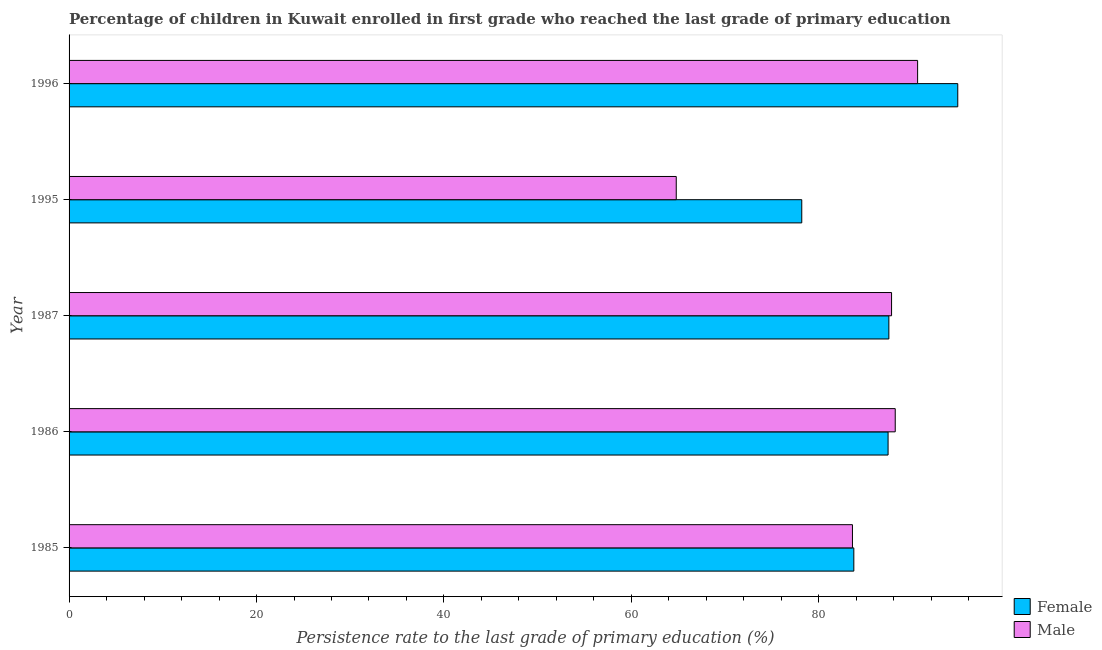How many different coloured bars are there?
Give a very brief answer. 2. Are the number of bars on each tick of the Y-axis equal?
Offer a very short reply. Yes. How many bars are there on the 1st tick from the top?
Offer a terse response. 2. How many bars are there on the 4th tick from the bottom?
Your response must be concise. 2. In how many cases, is the number of bars for a given year not equal to the number of legend labels?
Offer a terse response. 0. What is the persistence rate of male students in 1985?
Give a very brief answer. 83.59. Across all years, what is the maximum persistence rate of male students?
Your answer should be very brief. 90.54. Across all years, what is the minimum persistence rate of female students?
Make the answer very short. 78.18. What is the total persistence rate of female students in the graph?
Provide a short and direct response. 431.61. What is the difference between the persistence rate of female students in 1986 and that in 1996?
Keep it short and to the point. -7.43. What is the difference between the persistence rate of female students in 1985 and the persistence rate of male students in 1987?
Keep it short and to the point. -4.03. What is the average persistence rate of male students per year?
Give a very brief answer. 82.97. In the year 1996, what is the difference between the persistence rate of male students and persistence rate of female students?
Keep it short and to the point. -4.28. What is the ratio of the persistence rate of female students in 1985 to that in 1995?
Give a very brief answer. 1.07. Is the difference between the persistence rate of female students in 1985 and 1986 greater than the difference between the persistence rate of male students in 1985 and 1986?
Your answer should be very brief. Yes. What is the difference between the highest and the second highest persistence rate of female students?
Your answer should be very brief. 7.35. What is the difference between the highest and the lowest persistence rate of male students?
Your answer should be compact. 25.75. In how many years, is the persistence rate of female students greater than the average persistence rate of female students taken over all years?
Provide a short and direct response. 3. Is the sum of the persistence rate of female students in 1986 and 1996 greater than the maximum persistence rate of male students across all years?
Offer a terse response. Yes. How many bars are there?
Your response must be concise. 10. Does the graph contain any zero values?
Give a very brief answer. No. How many legend labels are there?
Ensure brevity in your answer.  2. How are the legend labels stacked?
Your answer should be compact. Vertical. What is the title of the graph?
Provide a succinct answer. Percentage of children in Kuwait enrolled in first grade who reached the last grade of primary education. Does "Foreign liabilities" appear as one of the legend labels in the graph?
Keep it short and to the point. No. What is the label or title of the X-axis?
Keep it short and to the point. Persistence rate to the last grade of primary education (%). What is the label or title of the Y-axis?
Provide a short and direct response. Year. What is the Persistence rate to the last grade of primary education (%) in Female in 1985?
Offer a terse response. 83.74. What is the Persistence rate to the last grade of primary education (%) of Male in 1985?
Your answer should be compact. 83.59. What is the Persistence rate to the last grade of primary education (%) of Female in 1986?
Your answer should be compact. 87.39. What is the Persistence rate to the last grade of primary education (%) of Male in 1986?
Give a very brief answer. 88.15. What is the Persistence rate to the last grade of primary education (%) in Female in 1987?
Your answer should be very brief. 87.47. What is the Persistence rate to the last grade of primary education (%) in Male in 1987?
Provide a short and direct response. 87.76. What is the Persistence rate to the last grade of primary education (%) of Female in 1995?
Ensure brevity in your answer.  78.18. What is the Persistence rate to the last grade of primary education (%) of Male in 1995?
Your response must be concise. 64.79. What is the Persistence rate to the last grade of primary education (%) of Female in 1996?
Offer a very short reply. 94.83. What is the Persistence rate to the last grade of primary education (%) of Male in 1996?
Keep it short and to the point. 90.54. Across all years, what is the maximum Persistence rate to the last grade of primary education (%) of Female?
Offer a very short reply. 94.83. Across all years, what is the maximum Persistence rate to the last grade of primary education (%) of Male?
Keep it short and to the point. 90.54. Across all years, what is the minimum Persistence rate to the last grade of primary education (%) in Female?
Your answer should be very brief. 78.18. Across all years, what is the minimum Persistence rate to the last grade of primary education (%) in Male?
Offer a very short reply. 64.79. What is the total Persistence rate to the last grade of primary education (%) of Female in the graph?
Your answer should be compact. 431.61. What is the total Persistence rate to the last grade of primary education (%) in Male in the graph?
Provide a short and direct response. 414.84. What is the difference between the Persistence rate to the last grade of primary education (%) in Female in 1985 and that in 1986?
Ensure brevity in your answer.  -3.66. What is the difference between the Persistence rate to the last grade of primary education (%) in Male in 1985 and that in 1986?
Your response must be concise. -4.57. What is the difference between the Persistence rate to the last grade of primary education (%) of Female in 1985 and that in 1987?
Give a very brief answer. -3.74. What is the difference between the Persistence rate to the last grade of primary education (%) in Male in 1985 and that in 1987?
Your answer should be compact. -4.17. What is the difference between the Persistence rate to the last grade of primary education (%) in Female in 1985 and that in 1995?
Offer a terse response. 5.55. What is the difference between the Persistence rate to the last grade of primary education (%) of Male in 1985 and that in 1995?
Make the answer very short. 18.8. What is the difference between the Persistence rate to the last grade of primary education (%) in Female in 1985 and that in 1996?
Provide a short and direct response. -11.09. What is the difference between the Persistence rate to the last grade of primary education (%) in Male in 1985 and that in 1996?
Offer a terse response. -6.95. What is the difference between the Persistence rate to the last grade of primary education (%) in Female in 1986 and that in 1987?
Offer a terse response. -0.08. What is the difference between the Persistence rate to the last grade of primary education (%) in Male in 1986 and that in 1987?
Your answer should be compact. 0.39. What is the difference between the Persistence rate to the last grade of primary education (%) in Female in 1986 and that in 1995?
Keep it short and to the point. 9.21. What is the difference between the Persistence rate to the last grade of primary education (%) in Male in 1986 and that in 1995?
Provide a short and direct response. 23.37. What is the difference between the Persistence rate to the last grade of primary education (%) in Female in 1986 and that in 1996?
Provide a short and direct response. -7.43. What is the difference between the Persistence rate to the last grade of primary education (%) in Male in 1986 and that in 1996?
Keep it short and to the point. -2.39. What is the difference between the Persistence rate to the last grade of primary education (%) of Female in 1987 and that in 1995?
Give a very brief answer. 9.29. What is the difference between the Persistence rate to the last grade of primary education (%) of Male in 1987 and that in 1995?
Give a very brief answer. 22.97. What is the difference between the Persistence rate to the last grade of primary education (%) of Female in 1987 and that in 1996?
Your answer should be compact. -7.35. What is the difference between the Persistence rate to the last grade of primary education (%) of Male in 1987 and that in 1996?
Your answer should be compact. -2.78. What is the difference between the Persistence rate to the last grade of primary education (%) in Female in 1995 and that in 1996?
Your response must be concise. -16.64. What is the difference between the Persistence rate to the last grade of primary education (%) in Male in 1995 and that in 1996?
Ensure brevity in your answer.  -25.75. What is the difference between the Persistence rate to the last grade of primary education (%) in Female in 1985 and the Persistence rate to the last grade of primary education (%) in Male in 1986?
Your response must be concise. -4.42. What is the difference between the Persistence rate to the last grade of primary education (%) in Female in 1985 and the Persistence rate to the last grade of primary education (%) in Male in 1987?
Give a very brief answer. -4.03. What is the difference between the Persistence rate to the last grade of primary education (%) of Female in 1985 and the Persistence rate to the last grade of primary education (%) of Male in 1995?
Your answer should be compact. 18.95. What is the difference between the Persistence rate to the last grade of primary education (%) of Female in 1985 and the Persistence rate to the last grade of primary education (%) of Male in 1996?
Give a very brief answer. -6.81. What is the difference between the Persistence rate to the last grade of primary education (%) in Female in 1986 and the Persistence rate to the last grade of primary education (%) in Male in 1987?
Give a very brief answer. -0.37. What is the difference between the Persistence rate to the last grade of primary education (%) in Female in 1986 and the Persistence rate to the last grade of primary education (%) in Male in 1995?
Keep it short and to the point. 22.6. What is the difference between the Persistence rate to the last grade of primary education (%) of Female in 1986 and the Persistence rate to the last grade of primary education (%) of Male in 1996?
Your response must be concise. -3.15. What is the difference between the Persistence rate to the last grade of primary education (%) in Female in 1987 and the Persistence rate to the last grade of primary education (%) in Male in 1995?
Give a very brief answer. 22.69. What is the difference between the Persistence rate to the last grade of primary education (%) of Female in 1987 and the Persistence rate to the last grade of primary education (%) of Male in 1996?
Keep it short and to the point. -3.07. What is the difference between the Persistence rate to the last grade of primary education (%) of Female in 1995 and the Persistence rate to the last grade of primary education (%) of Male in 1996?
Ensure brevity in your answer.  -12.36. What is the average Persistence rate to the last grade of primary education (%) in Female per year?
Make the answer very short. 86.32. What is the average Persistence rate to the last grade of primary education (%) in Male per year?
Ensure brevity in your answer.  82.97. In the year 1985, what is the difference between the Persistence rate to the last grade of primary education (%) of Female and Persistence rate to the last grade of primary education (%) of Male?
Offer a very short reply. 0.15. In the year 1986, what is the difference between the Persistence rate to the last grade of primary education (%) in Female and Persistence rate to the last grade of primary education (%) in Male?
Your answer should be very brief. -0.76. In the year 1987, what is the difference between the Persistence rate to the last grade of primary education (%) in Female and Persistence rate to the last grade of primary education (%) in Male?
Make the answer very short. -0.29. In the year 1995, what is the difference between the Persistence rate to the last grade of primary education (%) of Female and Persistence rate to the last grade of primary education (%) of Male?
Offer a terse response. 13.39. In the year 1996, what is the difference between the Persistence rate to the last grade of primary education (%) in Female and Persistence rate to the last grade of primary education (%) in Male?
Provide a succinct answer. 4.28. What is the ratio of the Persistence rate to the last grade of primary education (%) of Female in 1985 to that in 1986?
Keep it short and to the point. 0.96. What is the ratio of the Persistence rate to the last grade of primary education (%) of Male in 1985 to that in 1986?
Ensure brevity in your answer.  0.95. What is the ratio of the Persistence rate to the last grade of primary education (%) in Female in 1985 to that in 1987?
Your answer should be compact. 0.96. What is the ratio of the Persistence rate to the last grade of primary education (%) of Female in 1985 to that in 1995?
Provide a short and direct response. 1.07. What is the ratio of the Persistence rate to the last grade of primary education (%) of Male in 1985 to that in 1995?
Make the answer very short. 1.29. What is the ratio of the Persistence rate to the last grade of primary education (%) of Female in 1985 to that in 1996?
Your answer should be very brief. 0.88. What is the ratio of the Persistence rate to the last grade of primary education (%) of Male in 1985 to that in 1996?
Keep it short and to the point. 0.92. What is the ratio of the Persistence rate to the last grade of primary education (%) of Male in 1986 to that in 1987?
Offer a terse response. 1. What is the ratio of the Persistence rate to the last grade of primary education (%) in Female in 1986 to that in 1995?
Offer a terse response. 1.12. What is the ratio of the Persistence rate to the last grade of primary education (%) of Male in 1986 to that in 1995?
Your response must be concise. 1.36. What is the ratio of the Persistence rate to the last grade of primary education (%) in Female in 1986 to that in 1996?
Your answer should be compact. 0.92. What is the ratio of the Persistence rate to the last grade of primary education (%) in Male in 1986 to that in 1996?
Provide a short and direct response. 0.97. What is the ratio of the Persistence rate to the last grade of primary education (%) of Female in 1987 to that in 1995?
Provide a succinct answer. 1.12. What is the ratio of the Persistence rate to the last grade of primary education (%) of Male in 1987 to that in 1995?
Provide a short and direct response. 1.35. What is the ratio of the Persistence rate to the last grade of primary education (%) of Female in 1987 to that in 1996?
Ensure brevity in your answer.  0.92. What is the ratio of the Persistence rate to the last grade of primary education (%) in Male in 1987 to that in 1996?
Your answer should be very brief. 0.97. What is the ratio of the Persistence rate to the last grade of primary education (%) in Female in 1995 to that in 1996?
Ensure brevity in your answer.  0.82. What is the ratio of the Persistence rate to the last grade of primary education (%) of Male in 1995 to that in 1996?
Keep it short and to the point. 0.72. What is the difference between the highest and the second highest Persistence rate to the last grade of primary education (%) of Female?
Give a very brief answer. 7.35. What is the difference between the highest and the second highest Persistence rate to the last grade of primary education (%) of Male?
Give a very brief answer. 2.39. What is the difference between the highest and the lowest Persistence rate to the last grade of primary education (%) of Female?
Provide a short and direct response. 16.64. What is the difference between the highest and the lowest Persistence rate to the last grade of primary education (%) in Male?
Make the answer very short. 25.75. 